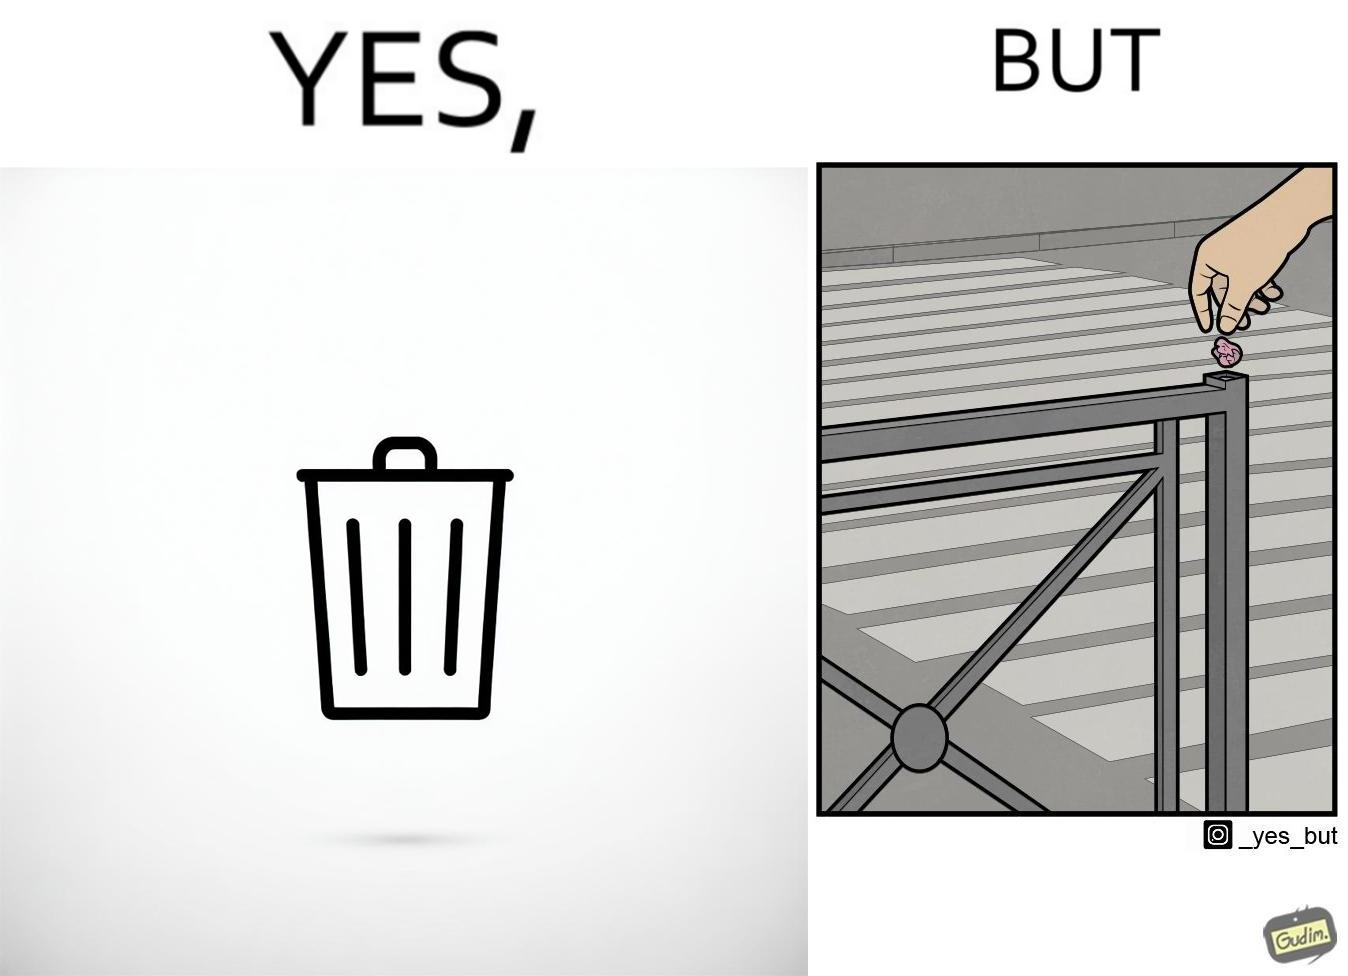Is this a satirical image? Yes, this image is satirical. 